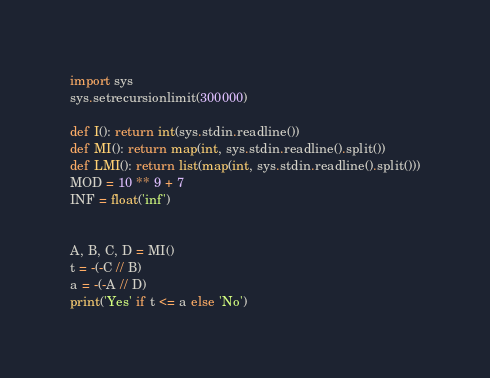<code> <loc_0><loc_0><loc_500><loc_500><_Python_>import sys
sys.setrecursionlimit(300000)

def I(): return int(sys.stdin.readline())
def MI(): return map(int, sys.stdin.readline().split())
def LMI(): return list(map(int, sys.stdin.readline().split()))
MOD = 10 ** 9 + 7
INF = float('inf')


A, B, C, D = MI()
t = -(-C // B)
a = -(-A // D)
print('Yes' if t <= a else 'No')
</code> 